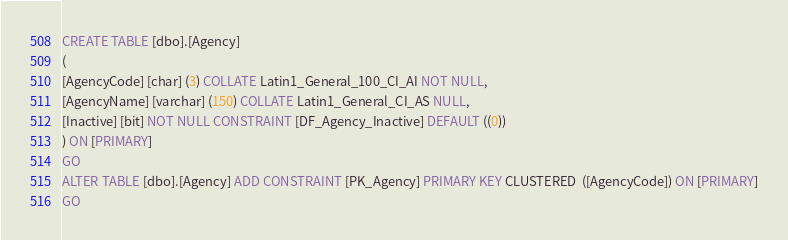Convert code to text. <code><loc_0><loc_0><loc_500><loc_500><_SQL_>CREATE TABLE [dbo].[Agency]
(
[AgencyCode] [char] (3) COLLATE Latin1_General_100_CI_AI NOT NULL,
[AgencyName] [varchar] (150) COLLATE Latin1_General_CI_AS NULL,
[Inactive] [bit] NOT NULL CONSTRAINT [DF_Agency_Inactive] DEFAULT ((0))
) ON [PRIMARY]
GO
ALTER TABLE [dbo].[Agency] ADD CONSTRAINT [PK_Agency] PRIMARY KEY CLUSTERED  ([AgencyCode]) ON [PRIMARY]
GO
</code> 